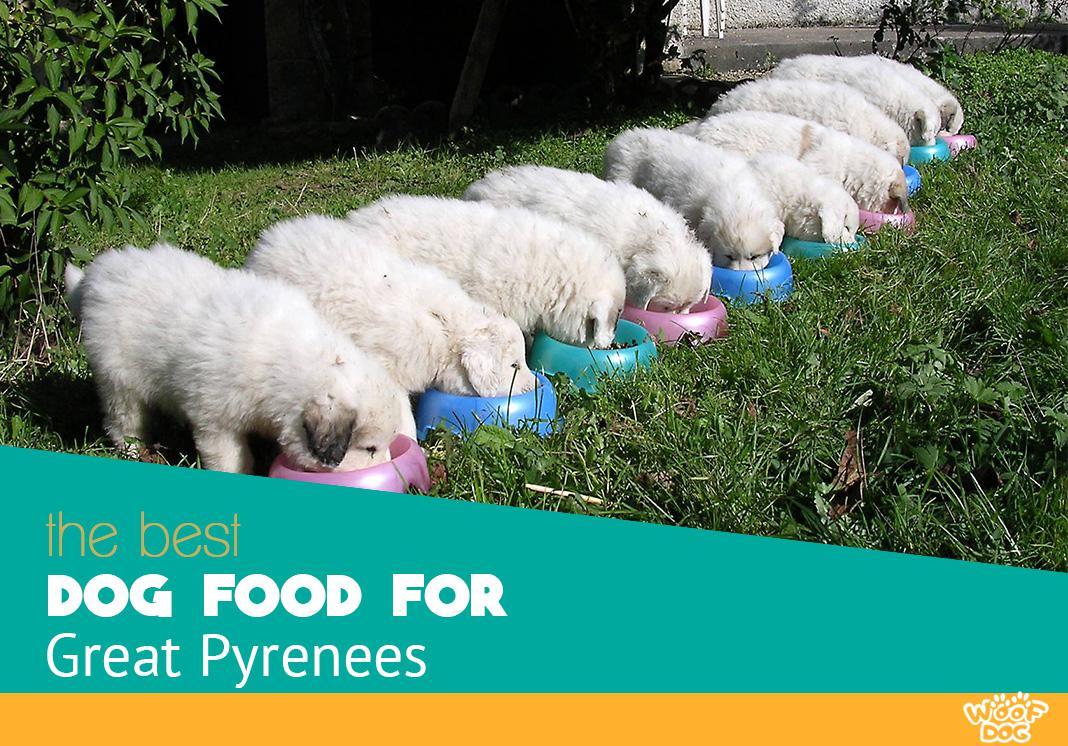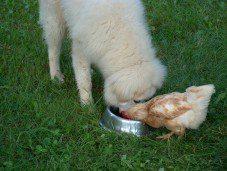The first image is the image on the left, the second image is the image on the right. Evaluate the accuracy of this statement regarding the images: "At least four dogs are eating from bowls in the image on the left.". Is it true? Answer yes or no. Yes. The first image is the image on the left, the second image is the image on the right. Given the left and right images, does the statement "An image shows a dog standing in front of a chair with only his hind legs on the floor." hold true? Answer yes or no. No. 